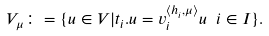<formula> <loc_0><loc_0><loc_500><loc_500>V _ { \mu } \colon = \{ u \in V | t _ { i } . u = v _ { i } ^ { \langle h _ { i } , \mu \rangle } u \ i \in I \} .</formula> 